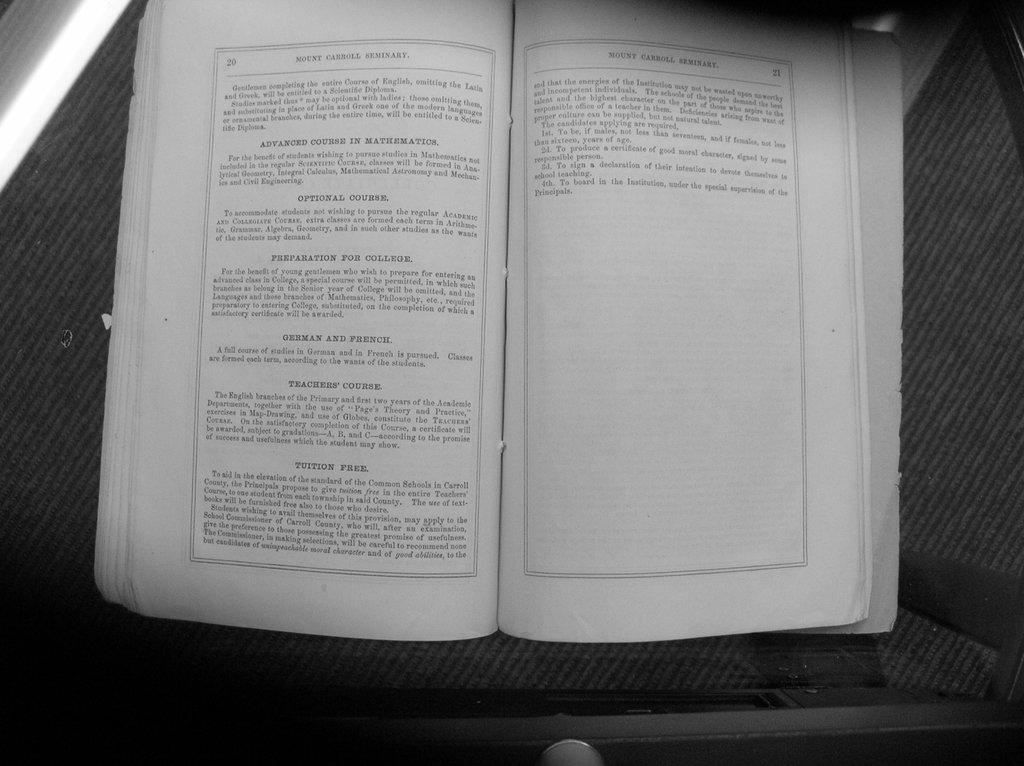<image>
Render a clear and concise summary of the photo. A book about Mount Carroll that's on page 20 